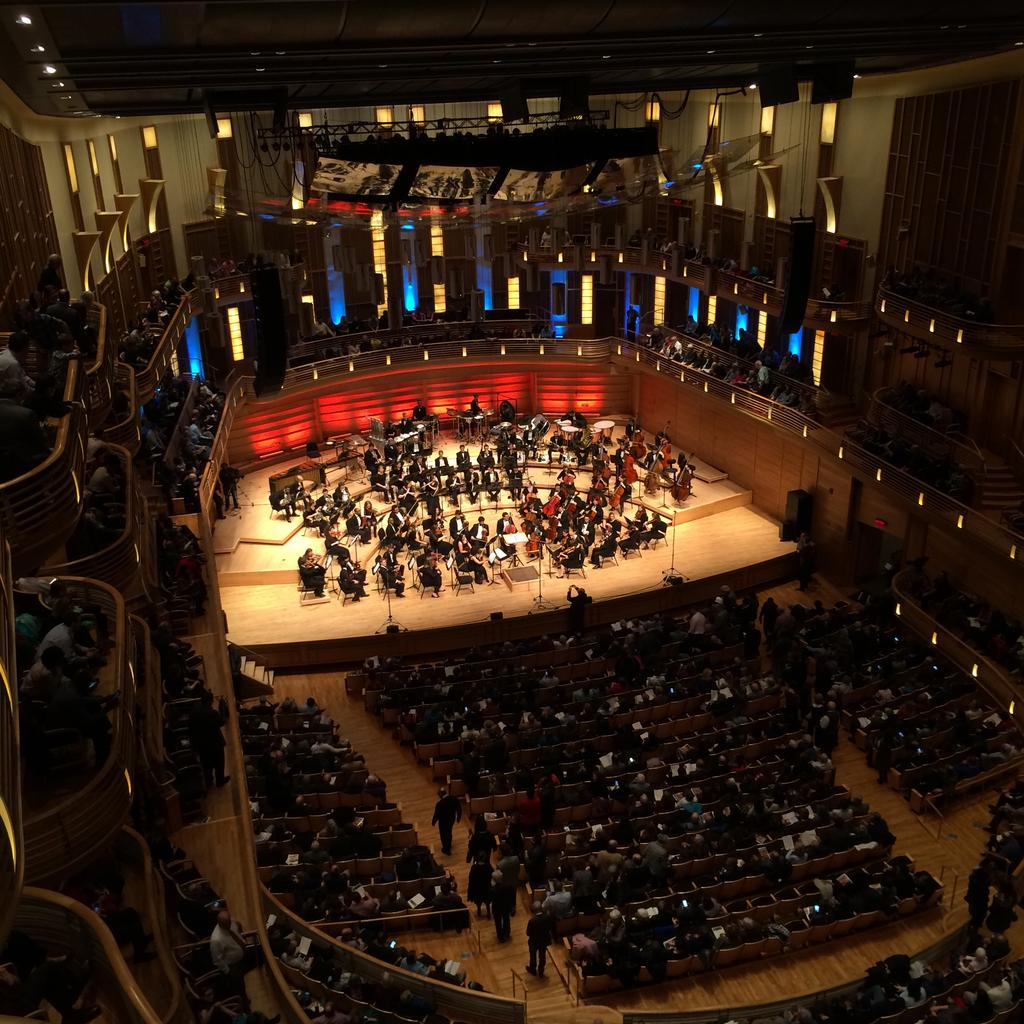What are the people in the image doing? The people in the image are playing musical instruments. Are there any other people in the image besides the musicians? Yes, there are audience members in the image. What can be seen in the background of the image? There are lights and windows with stained glass visible in the image. What type of bait is being used to catch fish in the image? There is no mention of fishing or bait in the image; it features people playing musical instruments and audience members. What kind of tooth is visible in the image? There is no tooth visible in the image. 